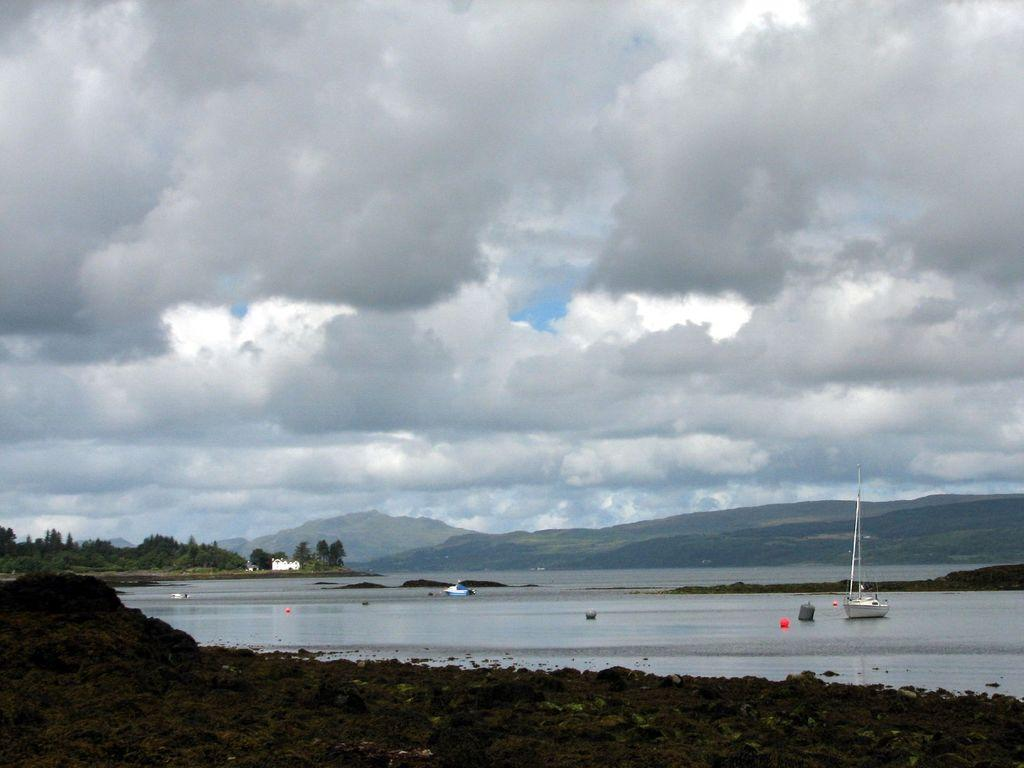What is on the water in the image? There are boats on the water in the image. What can be seen in the background of the image? There is a building, trees, hills, and the sky visible in the background of the image. What word is being exchanged between the boats in the image? There is no indication of any verbal exchange between the boats in the image. What type of floor can be seen in the image? The image does not show any floor; it features boats on water, a background with a building, trees, hills, and the sky. 